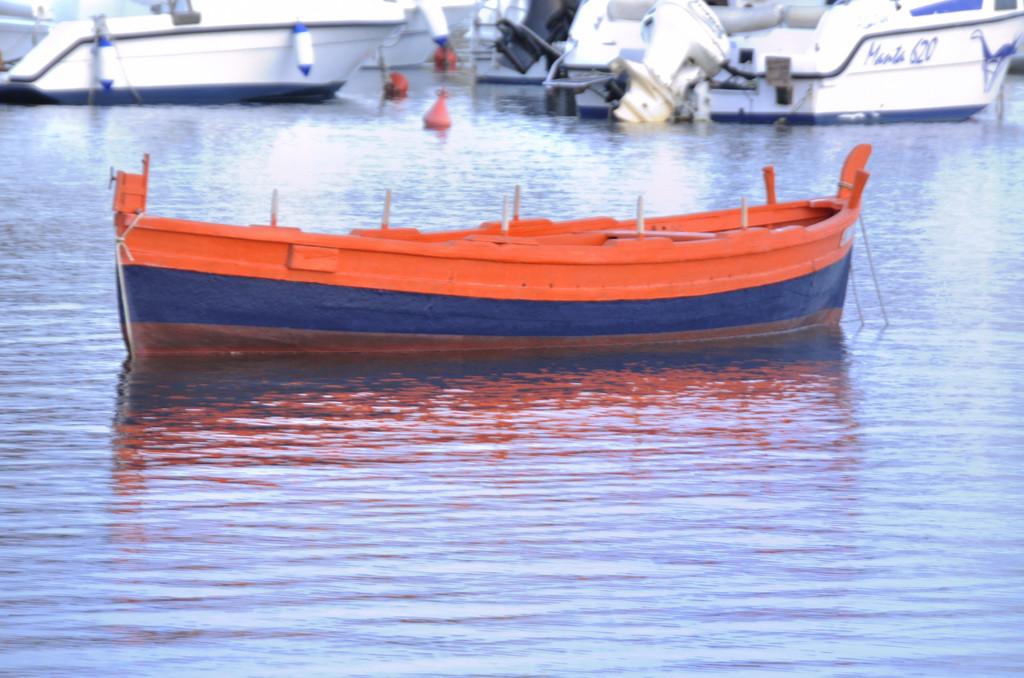What is the white boat called?
Offer a terse response. Manta 620. 